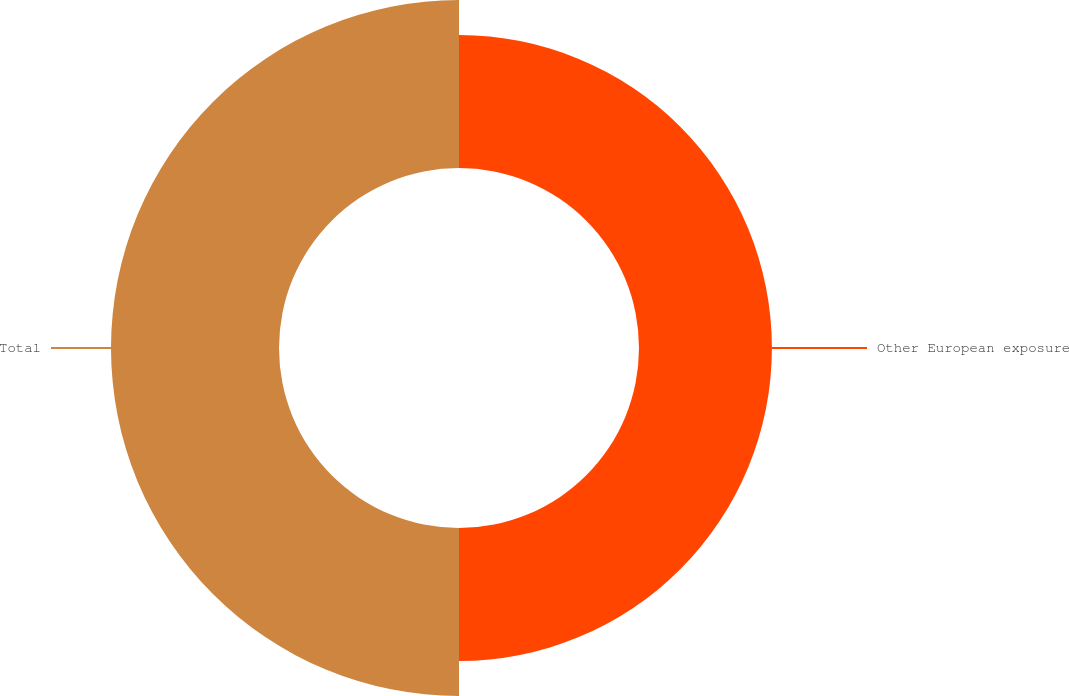<chart> <loc_0><loc_0><loc_500><loc_500><pie_chart><fcel>Other European exposure<fcel>Total<nl><fcel>44.17%<fcel>55.83%<nl></chart> 